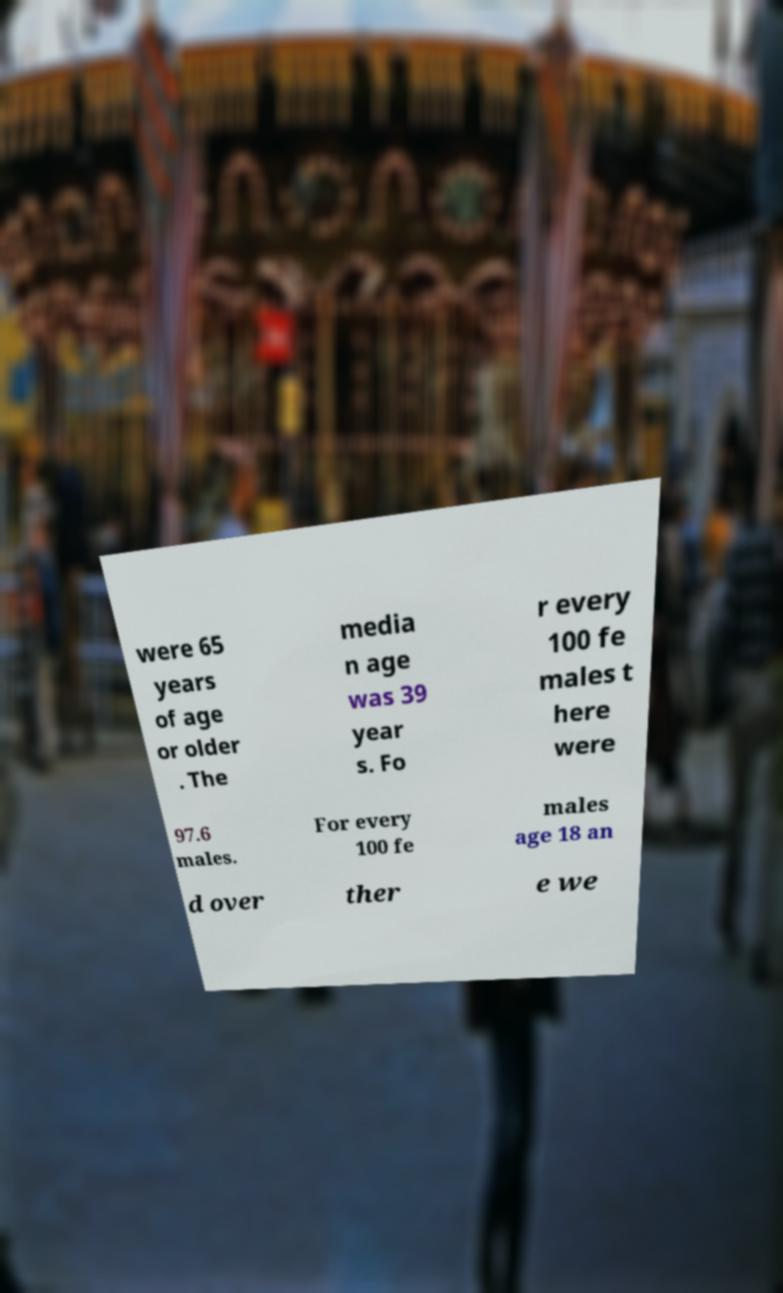Please read and relay the text visible in this image. What does it say? were 65 years of age or older . The media n age was 39 year s. Fo r every 100 fe males t here were 97.6 males. For every 100 fe males age 18 an d over ther e we 